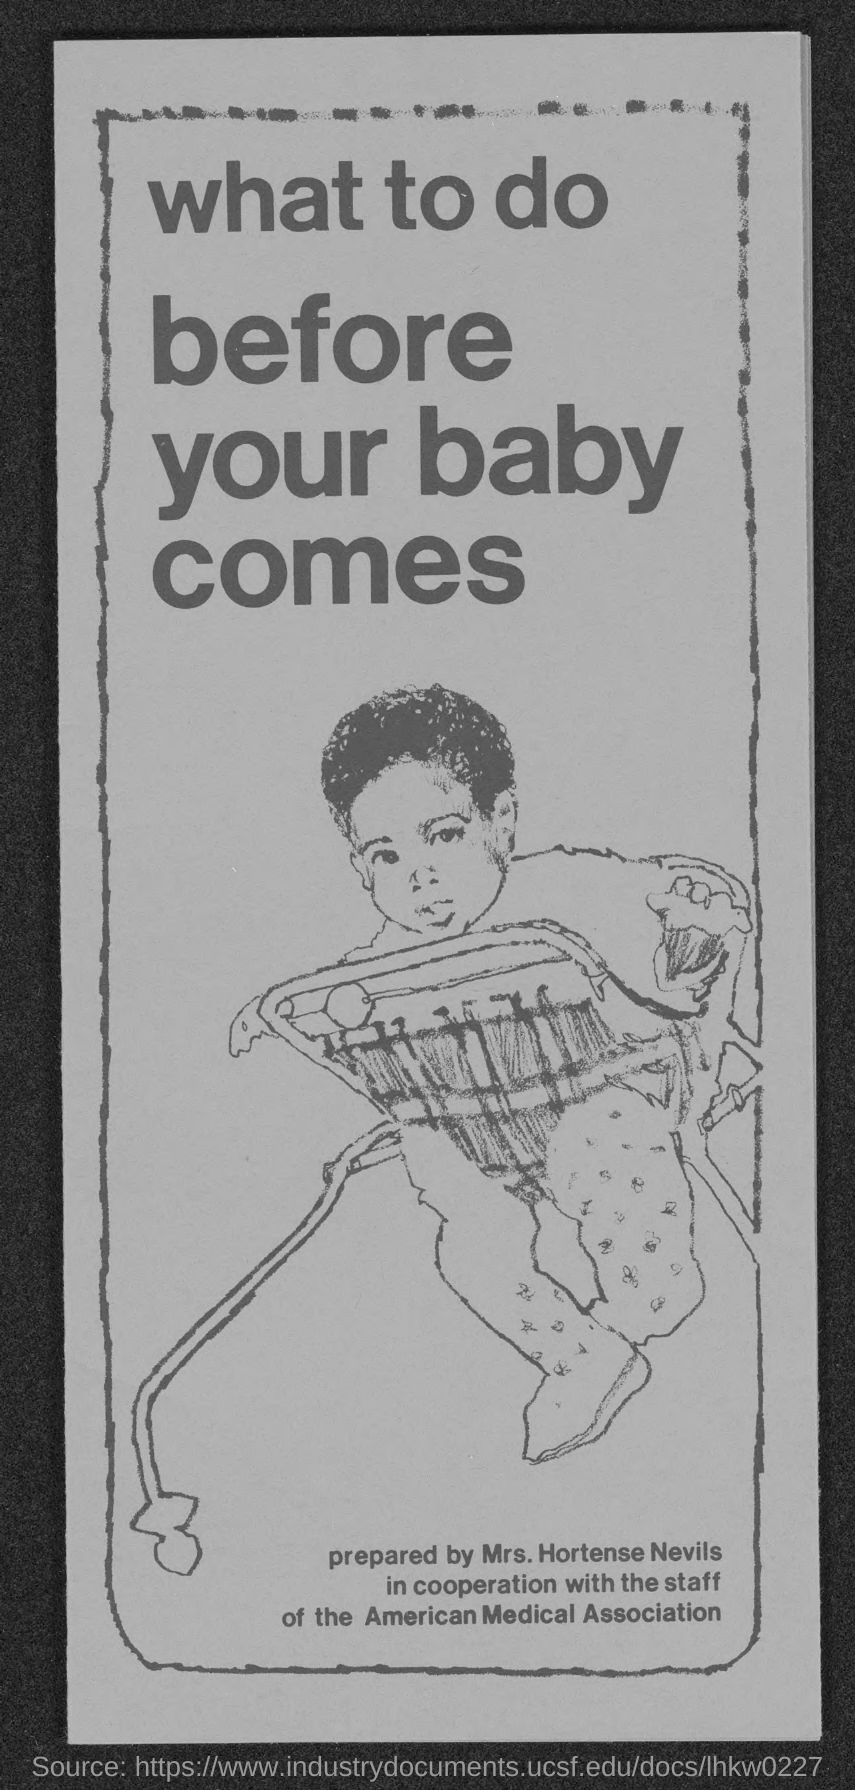Give some essential details in this illustration. Hortense Nevils prepared the document. 